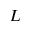<formula> <loc_0><loc_0><loc_500><loc_500>L</formula> 